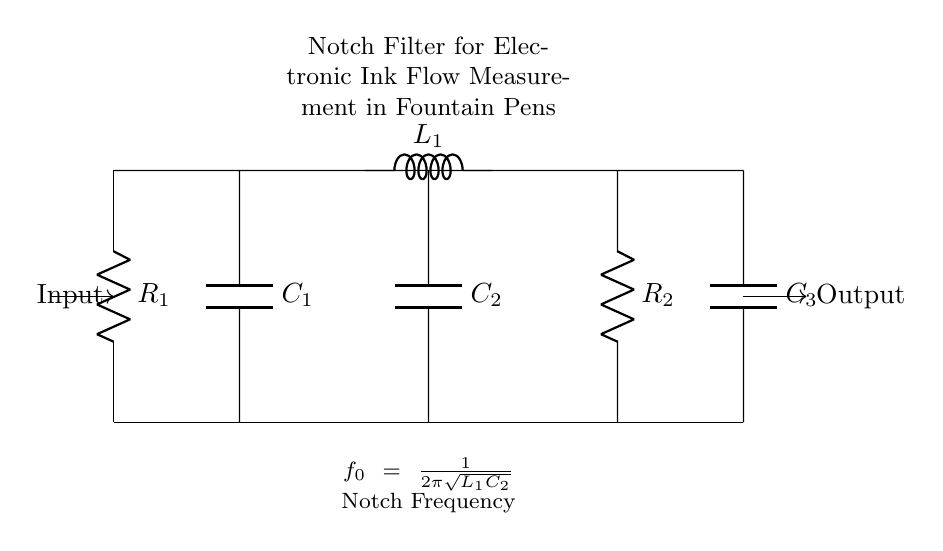What type of filter is represented in this circuit? The circuit is labeled as a Notch Filter, which is designed to eliminate specific frequencies from a signal. The presence of a notch frequency implies it blocks a particular band of frequencies while allowing others to pass.
Answer: Notch Filter What components are used in this notch filter? The circuit diagram includes resistors, capacitors, and an inductor. Specifically, it has R1, R2 for resistors; C1, C2, C3 for capacitors; and L1 for an inductor, indicating a combination of passive components used in filtering.
Answer: R1, R2, C1, C2, C3, L1 What is the function of the inductor in this circuit? The inductor's function in a notch filter is to create a resonant circuit with the capacitors, which enables the cancellation of certain frequencies at the notch frequency. The L1 inductor is crucial for the resonance necessary to define the notch filtering action.
Answer: Resonance creation What is the formula for the notch frequency? The information provided in the circuit indicates that the notch frequency formula is f0 = 1/(2π√(L1C2)). This formula expresses the relationship between the inductor and capacitor used to determine the filter's notch frequency, integrating both components effectively.
Answer: f0 = 1/(2π√(L1C2)) How many capacitors are present in this circuit? Upon reviewing the circuit diagram, there are three capacitors in total labeled C1, C2, and C3. A count shows clearly that they are integrated at specific locations in the circuit, enhancing its filtering ability.
Answer: Three What are the impedance characteristics of the components? The circuit typically involves resistive, capacitive, and inductive impedances. Capacitors have reactance that varies inversely with frequency, while inductors have reactance that varies directly, a key characteristic when analyzing filter behavior in this notch filter setup.
Answer: Resistive and reactive impedances 